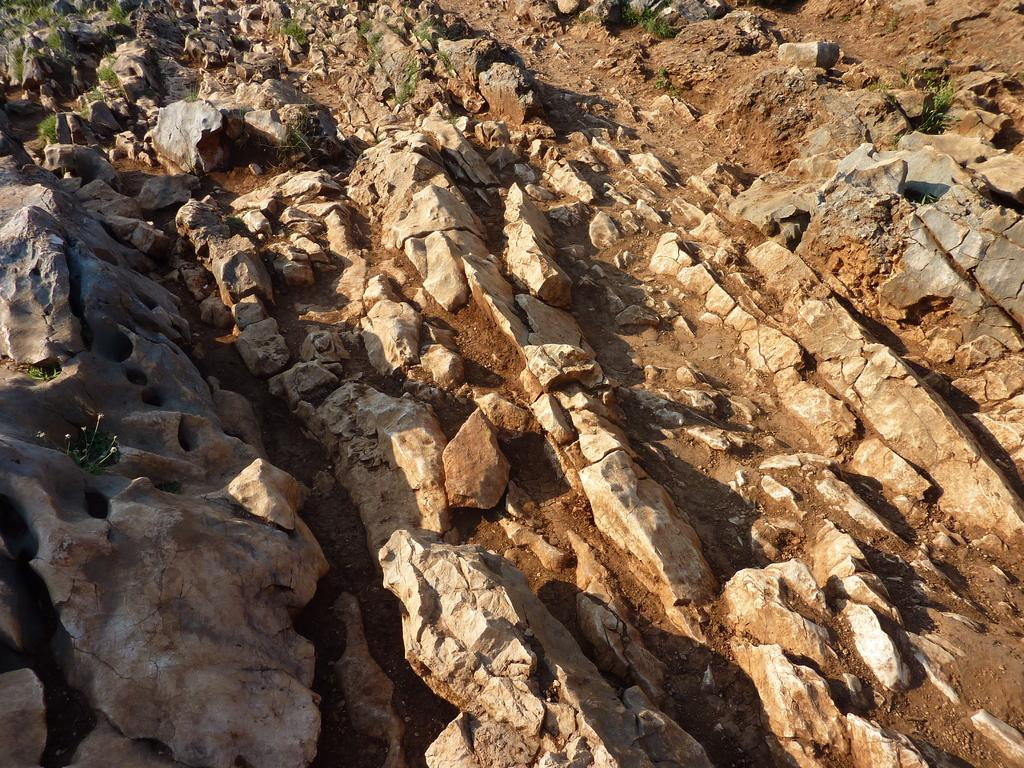What type of natural elements can be seen in the image? There are rocks, sand, and plants in the image. Can you describe the terrain in the image? The terrain in the image consists of rocks, sand, and plants. What type of vegetation is present in the image? There are plants in the image. What hobbies are the rocks and plants engaged in within the image? The rocks and plants are not engaged in any hobbies, as they are inanimate objects and cannot participate in human activities. 